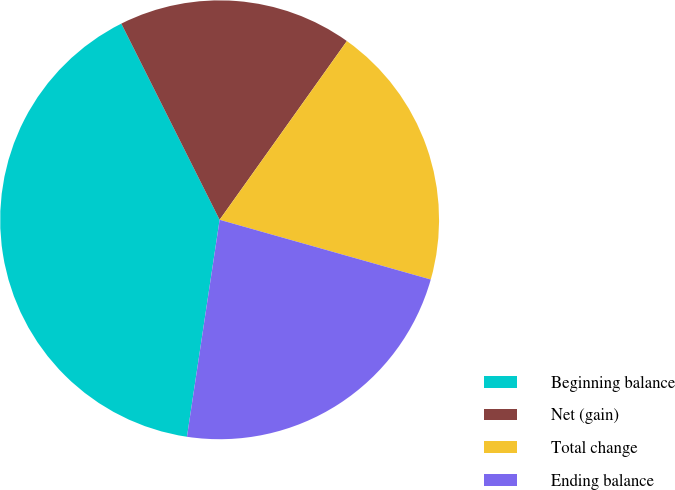<chart> <loc_0><loc_0><loc_500><loc_500><pie_chart><fcel>Beginning balance<fcel>Net (gain)<fcel>Total change<fcel>Ending balance<nl><fcel>40.23%<fcel>17.24%<fcel>19.54%<fcel>22.99%<nl></chart> 